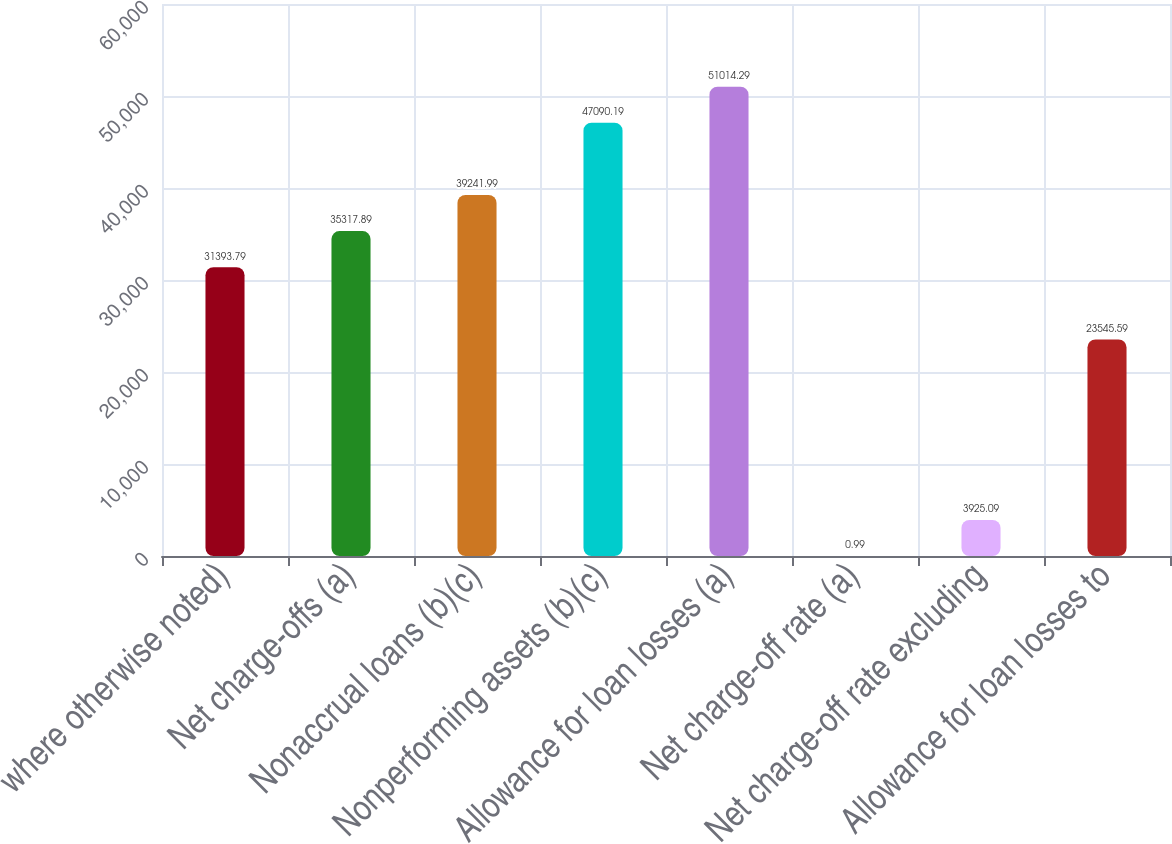Convert chart. <chart><loc_0><loc_0><loc_500><loc_500><bar_chart><fcel>where otherwise noted)<fcel>Net charge-offs (a)<fcel>Nonaccrual loans (b)(c)<fcel>Nonperforming assets (b)(c)<fcel>Allowance for loan losses (a)<fcel>Net charge-off rate (a)<fcel>Net charge-off rate excluding<fcel>Allowance for loan losses to<nl><fcel>31393.8<fcel>35317.9<fcel>39242<fcel>47090.2<fcel>51014.3<fcel>0.99<fcel>3925.09<fcel>23545.6<nl></chart> 